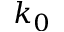Convert formula to latex. <formula><loc_0><loc_0><loc_500><loc_500>k _ { 0 }</formula> 